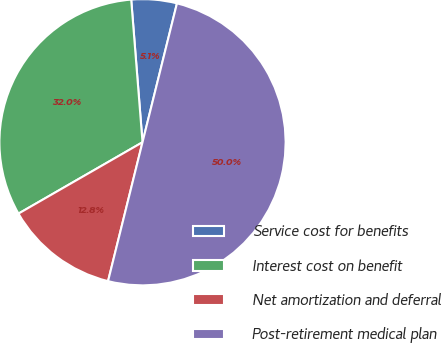<chart> <loc_0><loc_0><loc_500><loc_500><pie_chart><fcel>Service cost for benefits<fcel>Interest cost on benefit<fcel>Net amortization and deferral<fcel>Post-retirement medical plan<nl><fcel>5.13%<fcel>32.05%<fcel>12.82%<fcel>50.0%<nl></chart> 